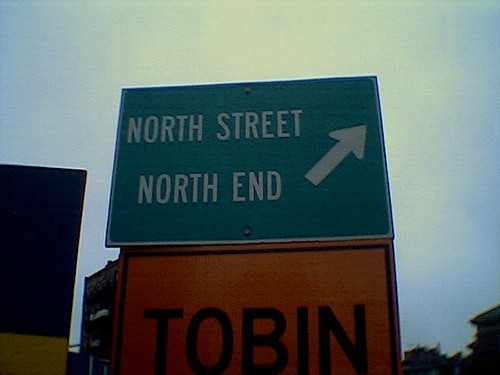Describe the objects in this image and their specific colors. I can see various objects in this image with different colors. 